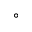Convert formula to latex. <formula><loc_0><loc_0><loc_500><loc_500>^ { \circ }</formula> 